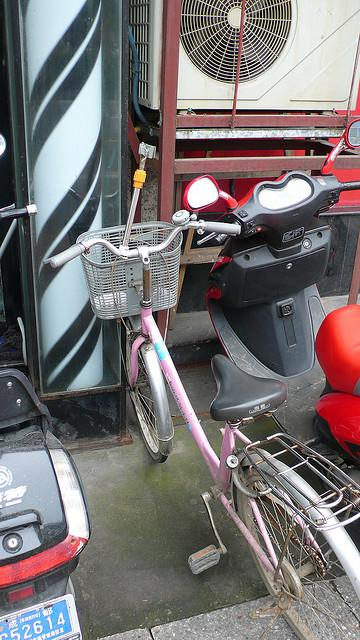What color is the frame of the girl's bike painted out to be?

Choices:
A) blue
B) pink
C) purple
D) yellow pink 